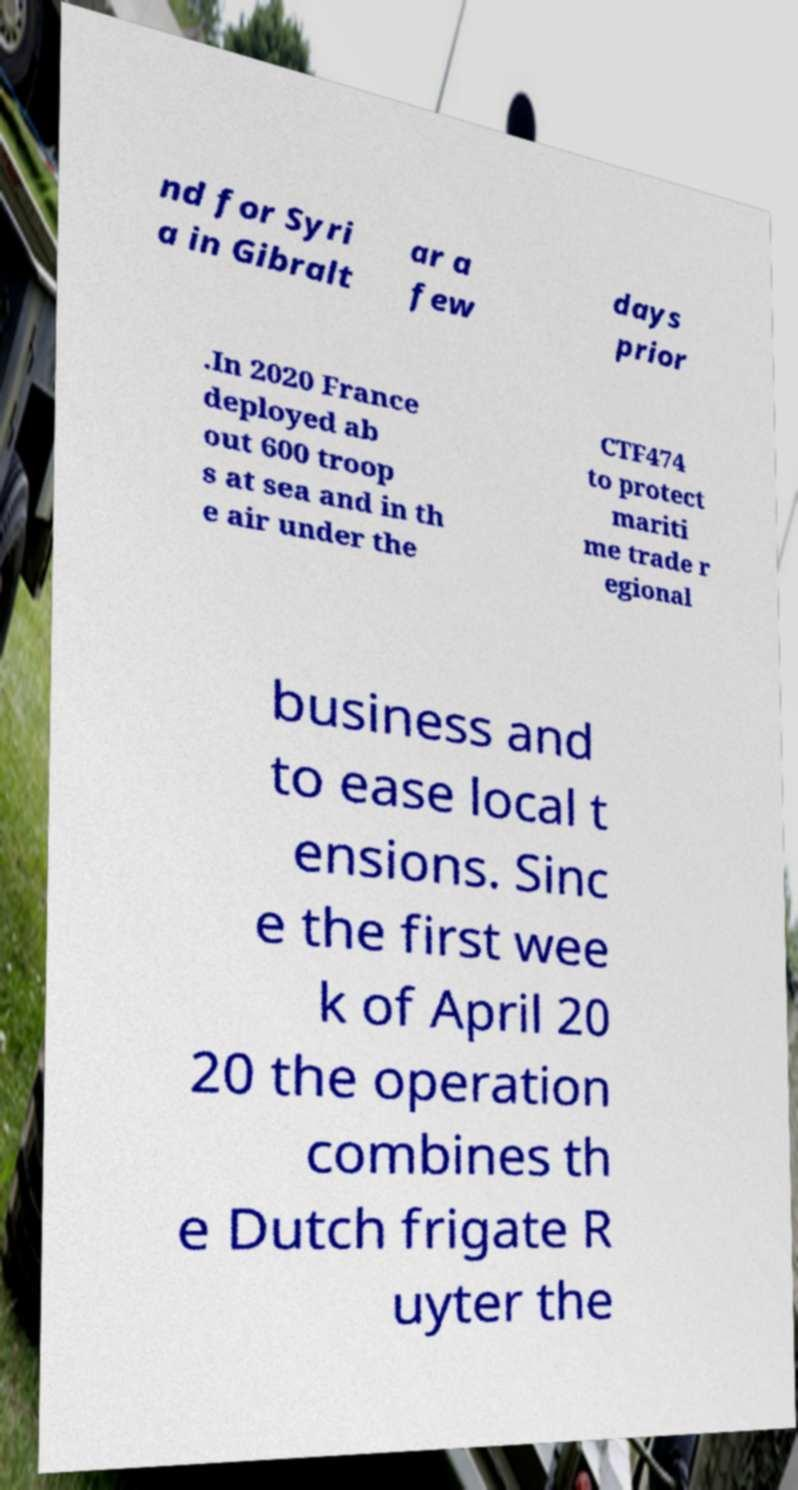Can you read and provide the text displayed in the image?This photo seems to have some interesting text. Can you extract and type it out for me? nd for Syri a in Gibralt ar a few days prior .In 2020 France deployed ab out 600 troop s at sea and in th e air under the CTF474 to protect mariti me trade r egional business and to ease local t ensions. Sinc e the first wee k of April 20 20 the operation combines th e Dutch frigate R uyter the 